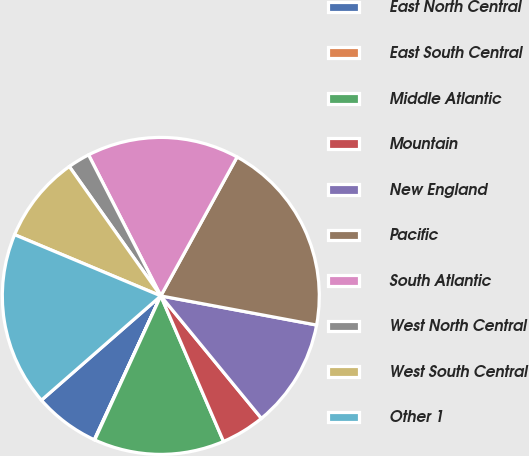Convert chart to OTSL. <chart><loc_0><loc_0><loc_500><loc_500><pie_chart><fcel>East North Central<fcel>East South Central<fcel>Middle Atlantic<fcel>Mountain<fcel>New England<fcel>Pacific<fcel>South Atlantic<fcel>West North Central<fcel>West South Central<fcel>Other 1<nl><fcel>6.68%<fcel>0.05%<fcel>13.32%<fcel>4.47%<fcel>11.11%<fcel>19.95%<fcel>15.53%<fcel>2.26%<fcel>8.89%<fcel>17.74%<nl></chart> 